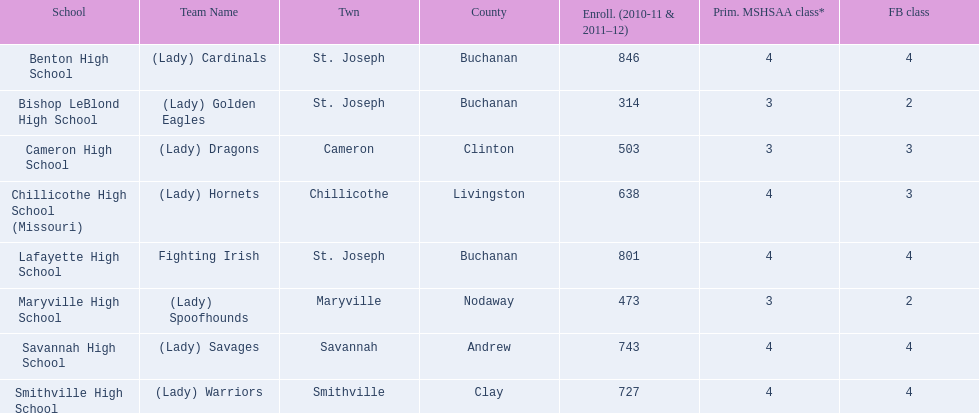What is the lowest number of students enrolled at a school as listed here? 314. What school has 314 students enrolled? Bishop LeBlond High School. 